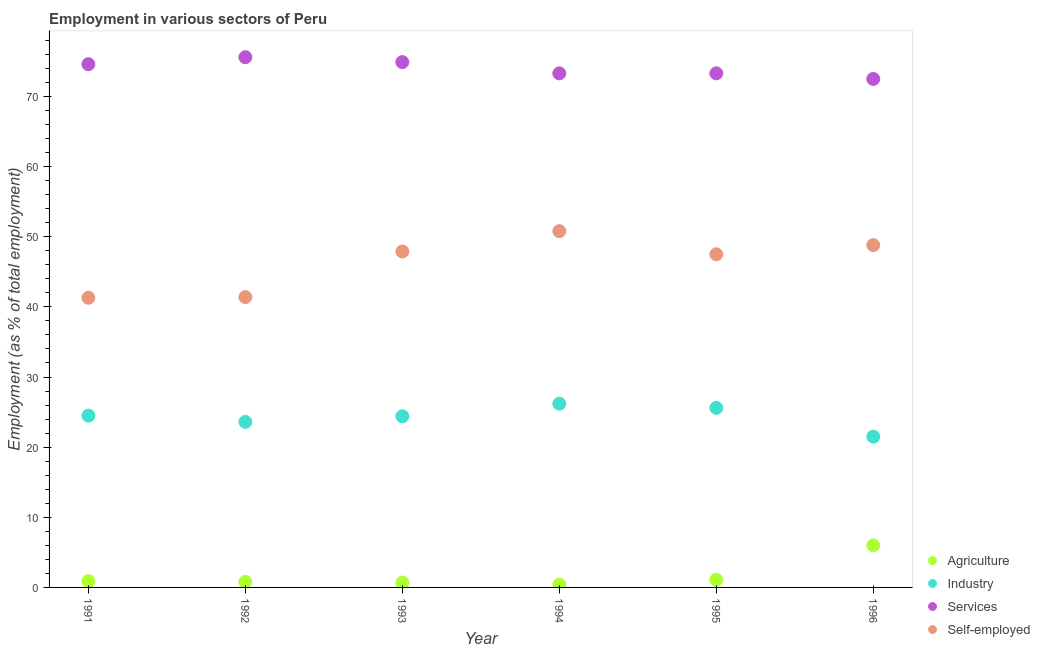How many different coloured dotlines are there?
Make the answer very short. 4. What is the percentage of workers in agriculture in 1992?
Keep it short and to the point. 0.8. Across all years, what is the maximum percentage of workers in agriculture?
Your answer should be very brief. 6. Across all years, what is the minimum percentage of workers in agriculture?
Keep it short and to the point. 0.4. In which year was the percentage of workers in agriculture maximum?
Offer a very short reply. 1996. In which year was the percentage of workers in services minimum?
Offer a terse response. 1996. What is the total percentage of self employed workers in the graph?
Your response must be concise. 277.7. What is the difference between the percentage of workers in agriculture in 1994 and that in 1995?
Provide a succinct answer. -0.7. What is the difference between the percentage of workers in agriculture in 1993 and the percentage of self employed workers in 1991?
Ensure brevity in your answer.  -40.6. What is the average percentage of workers in industry per year?
Keep it short and to the point. 24.3. In the year 1992, what is the difference between the percentage of self employed workers and percentage of workers in services?
Provide a succinct answer. -34.2. What is the ratio of the percentage of workers in services in 1992 to that in 1996?
Provide a short and direct response. 1.04. Is the difference between the percentage of workers in industry in 1991 and 1996 greater than the difference between the percentage of self employed workers in 1991 and 1996?
Provide a succinct answer. Yes. What is the difference between the highest and the second highest percentage of self employed workers?
Ensure brevity in your answer.  2. What is the difference between the highest and the lowest percentage of workers in industry?
Offer a terse response. 4.7. Is it the case that in every year, the sum of the percentage of workers in services and percentage of workers in agriculture is greater than the sum of percentage of workers in industry and percentage of self employed workers?
Keep it short and to the point. No. Is it the case that in every year, the sum of the percentage of workers in agriculture and percentage of workers in industry is greater than the percentage of workers in services?
Your answer should be compact. No. Is the percentage of workers in agriculture strictly less than the percentage of workers in industry over the years?
Your answer should be very brief. Yes. How many dotlines are there?
Offer a very short reply. 4. How many years are there in the graph?
Give a very brief answer. 6. What is the difference between two consecutive major ticks on the Y-axis?
Provide a succinct answer. 10. Are the values on the major ticks of Y-axis written in scientific E-notation?
Offer a very short reply. No. Does the graph contain any zero values?
Offer a very short reply. No. Does the graph contain grids?
Give a very brief answer. No. How many legend labels are there?
Offer a terse response. 4. How are the legend labels stacked?
Your answer should be very brief. Vertical. What is the title of the graph?
Your answer should be compact. Employment in various sectors of Peru. Does "UNHCR" appear as one of the legend labels in the graph?
Offer a terse response. No. What is the label or title of the X-axis?
Keep it short and to the point. Year. What is the label or title of the Y-axis?
Your response must be concise. Employment (as % of total employment). What is the Employment (as % of total employment) of Agriculture in 1991?
Your answer should be compact. 0.9. What is the Employment (as % of total employment) of Services in 1991?
Provide a succinct answer. 74.6. What is the Employment (as % of total employment) of Self-employed in 1991?
Offer a terse response. 41.3. What is the Employment (as % of total employment) in Agriculture in 1992?
Ensure brevity in your answer.  0.8. What is the Employment (as % of total employment) of Industry in 1992?
Offer a very short reply. 23.6. What is the Employment (as % of total employment) of Services in 1992?
Offer a very short reply. 75.6. What is the Employment (as % of total employment) in Self-employed in 1992?
Your answer should be very brief. 41.4. What is the Employment (as % of total employment) of Agriculture in 1993?
Give a very brief answer. 0.7. What is the Employment (as % of total employment) in Industry in 1993?
Provide a short and direct response. 24.4. What is the Employment (as % of total employment) of Services in 1993?
Ensure brevity in your answer.  74.9. What is the Employment (as % of total employment) in Self-employed in 1993?
Give a very brief answer. 47.9. What is the Employment (as % of total employment) of Agriculture in 1994?
Provide a succinct answer. 0.4. What is the Employment (as % of total employment) in Industry in 1994?
Ensure brevity in your answer.  26.2. What is the Employment (as % of total employment) in Services in 1994?
Provide a short and direct response. 73.3. What is the Employment (as % of total employment) in Self-employed in 1994?
Provide a short and direct response. 50.8. What is the Employment (as % of total employment) in Agriculture in 1995?
Provide a succinct answer. 1.1. What is the Employment (as % of total employment) in Industry in 1995?
Ensure brevity in your answer.  25.6. What is the Employment (as % of total employment) in Services in 1995?
Your response must be concise. 73.3. What is the Employment (as % of total employment) in Self-employed in 1995?
Give a very brief answer. 47.5. What is the Employment (as % of total employment) in Services in 1996?
Ensure brevity in your answer.  72.5. What is the Employment (as % of total employment) of Self-employed in 1996?
Give a very brief answer. 48.8. Across all years, what is the maximum Employment (as % of total employment) in Industry?
Ensure brevity in your answer.  26.2. Across all years, what is the maximum Employment (as % of total employment) of Services?
Keep it short and to the point. 75.6. Across all years, what is the maximum Employment (as % of total employment) of Self-employed?
Provide a succinct answer. 50.8. Across all years, what is the minimum Employment (as % of total employment) in Agriculture?
Offer a very short reply. 0.4. Across all years, what is the minimum Employment (as % of total employment) in Industry?
Provide a succinct answer. 21.5. Across all years, what is the minimum Employment (as % of total employment) of Services?
Provide a short and direct response. 72.5. Across all years, what is the minimum Employment (as % of total employment) in Self-employed?
Provide a succinct answer. 41.3. What is the total Employment (as % of total employment) in Industry in the graph?
Offer a terse response. 145.8. What is the total Employment (as % of total employment) in Services in the graph?
Give a very brief answer. 444.2. What is the total Employment (as % of total employment) in Self-employed in the graph?
Your response must be concise. 277.7. What is the difference between the Employment (as % of total employment) of Agriculture in 1991 and that in 1992?
Your answer should be compact. 0.1. What is the difference between the Employment (as % of total employment) in Industry in 1991 and that in 1992?
Your answer should be compact. 0.9. What is the difference between the Employment (as % of total employment) in Services in 1991 and that in 1992?
Your answer should be compact. -1. What is the difference between the Employment (as % of total employment) in Agriculture in 1991 and that in 1993?
Make the answer very short. 0.2. What is the difference between the Employment (as % of total employment) in Self-employed in 1991 and that in 1993?
Your response must be concise. -6.6. What is the difference between the Employment (as % of total employment) of Agriculture in 1991 and that in 1994?
Keep it short and to the point. 0.5. What is the difference between the Employment (as % of total employment) of Industry in 1991 and that in 1994?
Ensure brevity in your answer.  -1.7. What is the difference between the Employment (as % of total employment) in Services in 1991 and that in 1994?
Offer a terse response. 1.3. What is the difference between the Employment (as % of total employment) of Services in 1991 and that in 1995?
Provide a short and direct response. 1.3. What is the difference between the Employment (as % of total employment) of Self-employed in 1991 and that in 1995?
Give a very brief answer. -6.2. What is the difference between the Employment (as % of total employment) in Agriculture in 1991 and that in 1996?
Give a very brief answer. -5.1. What is the difference between the Employment (as % of total employment) in Industry in 1991 and that in 1996?
Provide a short and direct response. 3. What is the difference between the Employment (as % of total employment) in Industry in 1992 and that in 1993?
Make the answer very short. -0.8. What is the difference between the Employment (as % of total employment) of Services in 1992 and that in 1993?
Make the answer very short. 0.7. What is the difference between the Employment (as % of total employment) in Self-employed in 1992 and that in 1993?
Give a very brief answer. -6.5. What is the difference between the Employment (as % of total employment) of Agriculture in 1992 and that in 1994?
Make the answer very short. 0.4. What is the difference between the Employment (as % of total employment) in Industry in 1992 and that in 1994?
Offer a terse response. -2.6. What is the difference between the Employment (as % of total employment) of Self-employed in 1992 and that in 1994?
Your answer should be compact. -9.4. What is the difference between the Employment (as % of total employment) of Agriculture in 1992 and that in 1996?
Offer a terse response. -5.2. What is the difference between the Employment (as % of total employment) of Industry in 1992 and that in 1996?
Your answer should be very brief. 2.1. What is the difference between the Employment (as % of total employment) of Services in 1992 and that in 1996?
Your answer should be compact. 3.1. What is the difference between the Employment (as % of total employment) in Self-employed in 1992 and that in 1996?
Provide a short and direct response. -7.4. What is the difference between the Employment (as % of total employment) in Agriculture in 1993 and that in 1994?
Offer a terse response. 0.3. What is the difference between the Employment (as % of total employment) of Industry in 1993 and that in 1994?
Keep it short and to the point. -1.8. What is the difference between the Employment (as % of total employment) of Self-employed in 1993 and that in 1994?
Ensure brevity in your answer.  -2.9. What is the difference between the Employment (as % of total employment) in Agriculture in 1993 and that in 1995?
Keep it short and to the point. -0.4. What is the difference between the Employment (as % of total employment) in Services in 1993 and that in 1995?
Your response must be concise. 1.6. What is the difference between the Employment (as % of total employment) of Self-employed in 1993 and that in 1995?
Provide a succinct answer. 0.4. What is the difference between the Employment (as % of total employment) of Self-employed in 1993 and that in 1996?
Offer a terse response. -0.9. What is the difference between the Employment (as % of total employment) in Services in 1994 and that in 1995?
Keep it short and to the point. 0. What is the difference between the Employment (as % of total employment) of Agriculture in 1994 and that in 1996?
Keep it short and to the point. -5.6. What is the difference between the Employment (as % of total employment) of Services in 1994 and that in 1996?
Offer a very short reply. 0.8. What is the difference between the Employment (as % of total employment) in Industry in 1995 and that in 1996?
Provide a short and direct response. 4.1. What is the difference between the Employment (as % of total employment) in Agriculture in 1991 and the Employment (as % of total employment) in Industry in 1992?
Your answer should be very brief. -22.7. What is the difference between the Employment (as % of total employment) in Agriculture in 1991 and the Employment (as % of total employment) in Services in 1992?
Your answer should be very brief. -74.7. What is the difference between the Employment (as % of total employment) in Agriculture in 1991 and the Employment (as % of total employment) in Self-employed in 1992?
Your answer should be very brief. -40.5. What is the difference between the Employment (as % of total employment) in Industry in 1991 and the Employment (as % of total employment) in Services in 1992?
Your response must be concise. -51.1. What is the difference between the Employment (as % of total employment) in Industry in 1991 and the Employment (as % of total employment) in Self-employed in 1992?
Your response must be concise. -16.9. What is the difference between the Employment (as % of total employment) in Services in 1991 and the Employment (as % of total employment) in Self-employed in 1992?
Offer a very short reply. 33.2. What is the difference between the Employment (as % of total employment) of Agriculture in 1991 and the Employment (as % of total employment) of Industry in 1993?
Your answer should be very brief. -23.5. What is the difference between the Employment (as % of total employment) of Agriculture in 1991 and the Employment (as % of total employment) of Services in 1993?
Your answer should be very brief. -74. What is the difference between the Employment (as % of total employment) in Agriculture in 1991 and the Employment (as % of total employment) in Self-employed in 1993?
Ensure brevity in your answer.  -47. What is the difference between the Employment (as % of total employment) in Industry in 1991 and the Employment (as % of total employment) in Services in 1993?
Offer a very short reply. -50.4. What is the difference between the Employment (as % of total employment) of Industry in 1991 and the Employment (as % of total employment) of Self-employed in 1993?
Your answer should be very brief. -23.4. What is the difference between the Employment (as % of total employment) of Services in 1991 and the Employment (as % of total employment) of Self-employed in 1993?
Make the answer very short. 26.7. What is the difference between the Employment (as % of total employment) in Agriculture in 1991 and the Employment (as % of total employment) in Industry in 1994?
Offer a very short reply. -25.3. What is the difference between the Employment (as % of total employment) of Agriculture in 1991 and the Employment (as % of total employment) of Services in 1994?
Offer a very short reply. -72.4. What is the difference between the Employment (as % of total employment) of Agriculture in 1991 and the Employment (as % of total employment) of Self-employed in 1994?
Make the answer very short. -49.9. What is the difference between the Employment (as % of total employment) in Industry in 1991 and the Employment (as % of total employment) in Services in 1994?
Offer a very short reply. -48.8. What is the difference between the Employment (as % of total employment) of Industry in 1991 and the Employment (as % of total employment) of Self-employed in 1994?
Your answer should be very brief. -26.3. What is the difference between the Employment (as % of total employment) of Services in 1991 and the Employment (as % of total employment) of Self-employed in 1994?
Your response must be concise. 23.8. What is the difference between the Employment (as % of total employment) in Agriculture in 1991 and the Employment (as % of total employment) in Industry in 1995?
Keep it short and to the point. -24.7. What is the difference between the Employment (as % of total employment) of Agriculture in 1991 and the Employment (as % of total employment) of Services in 1995?
Make the answer very short. -72.4. What is the difference between the Employment (as % of total employment) of Agriculture in 1991 and the Employment (as % of total employment) of Self-employed in 1995?
Make the answer very short. -46.6. What is the difference between the Employment (as % of total employment) of Industry in 1991 and the Employment (as % of total employment) of Services in 1995?
Your response must be concise. -48.8. What is the difference between the Employment (as % of total employment) in Services in 1991 and the Employment (as % of total employment) in Self-employed in 1995?
Make the answer very short. 27.1. What is the difference between the Employment (as % of total employment) of Agriculture in 1991 and the Employment (as % of total employment) of Industry in 1996?
Give a very brief answer. -20.6. What is the difference between the Employment (as % of total employment) in Agriculture in 1991 and the Employment (as % of total employment) in Services in 1996?
Provide a short and direct response. -71.6. What is the difference between the Employment (as % of total employment) of Agriculture in 1991 and the Employment (as % of total employment) of Self-employed in 1996?
Provide a short and direct response. -47.9. What is the difference between the Employment (as % of total employment) in Industry in 1991 and the Employment (as % of total employment) in Services in 1996?
Make the answer very short. -48. What is the difference between the Employment (as % of total employment) of Industry in 1991 and the Employment (as % of total employment) of Self-employed in 1996?
Provide a short and direct response. -24.3. What is the difference between the Employment (as % of total employment) of Services in 1991 and the Employment (as % of total employment) of Self-employed in 1996?
Give a very brief answer. 25.8. What is the difference between the Employment (as % of total employment) of Agriculture in 1992 and the Employment (as % of total employment) of Industry in 1993?
Your answer should be compact. -23.6. What is the difference between the Employment (as % of total employment) of Agriculture in 1992 and the Employment (as % of total employment) of Services in 1993?
Ensure brevity in your answer.  -74.1. What is the difference between the Employment (as % of total employment) of Agriculture in 1992 and the Employment (as % of total employment) of Self-employed in 1993?
Provide a short and direct response. -47.1. What is the difference between the Employment (as % of total employment) in Industry in 1992 and the Employment (as % of total employment) in Services in 1993?
Your answer should be compact. -51.3. What is the difference between the Employment (as % of total employment) in Industry in 1992 and the Employment (as % of total employment) in Self-employed in 1993?
Provide a succinct answer. -24.3. What is the difference between the Employment (as % of total employment) of Services in 1992 and the Employment (as % of total employment) of Self-employed in 1993?
Provide a succinct answer. 27.7. What is the difference between the Employment (as % of total employment) in Agriculture in 1992 and the Employment (as % of total employment) in Industry in 1994?
Your answer should be very brief. -25.4. What is the difference between the Employment (as % of total employment) of Agriculture in 1992 and the Employment (as % of total employment) of Services in 1994?
Offer a very short reply. -72.5. What is the difference between the Employment (as % of total employment) of Agriculture in 1992 and the Employment (as % of total employment) of Self-employed in 1994?
Your answer should be very brief. -50. What is the difference between the Employment (as % of total employment) of Industry in 1992 and the Employment (as % of total employment) of Services in 1994?
Provide a succinct answer. -49.7. What is the difference between the Employment (as % of total employment) of Industry in 1992 and the Employment (as % of total employment) of Self-employed in 1994?
Keep it short and to the point. -27.2. What is the difference between the Employment (as % of total employment) of Services in 1992 and the Employment (as % of total employment) of Self-employed in 1994?
Provide a succinct answer. 24.8. What is the difference between the Employment (as % of total employment) of Agriculture in 1992 and the Employment (as % of total employment) of Industry in 1995?
Offer a very short reply. -24.8. What is the difference between the Employment (as % of total employment) of Agriculture in 1992 and the Employment (as % of total employment) of Services in 1995?
Make the answer very short. -72.5. What is the difference between the Employment (as % of total employment) in Agriculture in 1992 and the Employment (as % of total employment) in Self-employed in 1995?
Your answer should be very brief. -46.7. What is the difference between the Employment (as % of total employment) in Industry in 1992 and the Employment (as % of total employment) in Services in 1995?
Provide a succinct answer. -49.7. What is the difference between the Employment (as % of total employment) of Industry in 1992 and the Employment (as % of total employment) of Self-employed in 1995?
Your answer should be compact. -23.9. What is the difference between the Employment (as % of total employment) in Services in 1992 and the Employment (as % of total employment) in Self-employed in 1995?
Your answer should be very brief. 28.1. What is the difference between the Employment (as % of total employment) in Agriculture in 1992 and the Employment (as % of total employment) in Industry in 1996?
Your answer should be compact. -20.7. What is the difference between the Employment (as % of total employment) in Agriculture in 1992 and the Employment (as % of total employment) in Services in 1996?
Ensure brevity in your answer.  -71.7. What is the difference between the Employment (as % of total employment) in Agriculture in 1992 and the Employment (as % of total employment) in Self-employed in 1996?
Offer a very short reply. -48. What is the difference between the Employment (as % of total employment) in Industry in 1992 and the Employment (as % of total employment) in Services in 1996?
Ensure brevity in your answer.  -48.9. What is the difference between the Employment (as % of total employment) in Industry in 1992 and the Employment (as % of total employment) in Self-employed in 1996?
Provide a short and direct response. -25.2. What is the difference between the Employment (as % of total employment) in Services in 1992 and the Employment (as % of total employment) in Self-employed in 1996?
Provide a short and direct response. 26.8. What is the difference between the Employment (as % of total employment) of Agriculture in 1993 and the Employment (as % of total employment) of Industry in 1994?
Provide a short and direct response. -25.5. What is the difference between the Employment (as % of total employment) in Agriculture in 1993 and the Employment (as % of total employment) in Services in 1994?
Give a very brief answer. -72.6. What is the difference between the Employment (as % of total employment) of Agriculture in 1993 and the Employment (as % of total employment) of Self-employed in 1994?
Your answer should be very brief. -50.1. What is the difference between the Employment (as % of total employment) of Industry in 1993 and the Employment (as % of total employment) of Services in 1994?
Your answer should be compact. -48.9. What is the difference between the Employment (as % of total employment) of Industry in 1993 and the Employment (as % of total employment) of Self-employed in 1994?
Offer a terse response. -26.4. What is the difference between the Employment (as % of total employment) of Services in 1993 and the Employment (as % of total employment) of Self-employed in 1994?
Give a very brief answer. 24.1. What is the difference between the Employment (as % of total employment) in Agriculture in 1993 and the Employment (as % of total employment) in Industry in 1995?
Provide a short and direct response. -24.9. What is the difference between the Employment (as % of total employment) of Agriculture in 1993 and the Employment (as % of total employment) of Services in 1995?
Your answer should be compact. -72.6. What is the difference between the Employment (as % of total employment) of Agriculture in 1993 and the Employment (as % of total employment) of Self-employed in 1995?
Offer a terse response. -46.8. What is the difference between the Employment (as % of total employment) of Industry in 1993 and the Employment (as % of total employment) of Services in 1995?
Offer a very short reply. -48.9. What is the difference between the Employment (as % of total employment) in Industry in 1993 and the Employment (as % of total employment) in Self-employed in 1995?
Ensure brevity in your answer.  -23.1. What is the difference between the Employment (as % of total employment) in Services in 1993 and the Employment (as % of total employment) in Self-employed in 1995?
Offer a terse response. 27.4. What is the difference between the Employment (as % of total employment) in Agriculture in 1993 and the Employment (as % of total employment) in Industry in 1996?
Provide a short and direct response. -20.8. What is the difference between the Employment (as % of total employment) in Agriculture in 1993 and the Employment (as % of total employment) in Services in 1996?
Provide a short and direct response. -71.8. What is the difference between the Employment (as % of total employment) in Agriculture in 1993 and the Employment (as % of total employment) in Self-employed in 1996?
Your answer should be very brief. -48.1. What is the difference between the Employment (as % of total employment) of Industry in 1993 and the Employment (as % of total employment) of Services in 1996?
Give a very brief answer. -48.1. What is the difference between the Employment (as % of total employment) of Industry in 1993 and the Employment (as % of total employment) of Self-employed in 1996?
Provide a short and direct response. -24.4. What is the difference between the Employment (as % of total employment) of Services in 1993 and the Employment (as % of total employment) of Self-employed in 1996?
Your answer should be compact. 26.1. What is the difference between the Employment (as % of total employment) in Agriculture in 1994 and the Employment (as % of total employment) in Industry in 1995?
Provide a short and direct response. -25.2. What is the difference between the Employment (as % of total employment) of Agriculture in 1994 and the Employment (as % of total employment) of Services in 1995?
Your answer should be very brief. -72.9. What is the difference between the Employment (as % of total employment) in Agriculture in 1994 and the Employment (as % of total employment) in Self-employed in 1995?
Provide a short and direct response. -47.1. What is the difference between the Employment (as % of total employment) of Industry in 1994 and the Employment (as % of total employment) of Services in 1995?
Offer a terse response. -47.1. What is the difference between the Employment (as % of total employment) of Industry in 1994 and the Employment (as % of total employment) of Self-employed in 1995?
Ensure brevity in your answer.  -21.3. What is the difference between the Employment (as % of total employment) in Services in 1994 and the Employment (as % of total employment) in Self-employed in 1995?
Provide a succinct answer. 25.8. What is the difference between the Employment (as % of total employment) of Agriculture in 1994 and the Employment (as % of total employment) of Industry in 1996?
Offer a very short reply. -21.1. What is the difference between the Employment (as % of total employment) of Agriculture in 1994 and the Employment (as % of total employment) of Services in 1996?
Offer a terse response. -72.1. What is the difference between the Employment (as % of total employment) in Agriculture in 1994 and the Employment (as % of total employment) in Self-employed in 1996?
Offer a terse response. -48.4. What is the difference between the Employment (as % of total employment) of Industry in 1994 and the Employment (as % of total employment) of Services in 1996?
Provide a short and direct response. -46.3. What is the difference between the Employment (as % of total employment) in Industry in 1994 and the Employment (as % of total employment) in Self-employed in 1996?
Provide a succinct answer. -22.6. What is the difference between the Employment (as % of total employment) of Services in 1994 and the Employment (as % of total employment) of Self-employed in 1996?
Keep it short and to the point. 24.5. What is the difference between the Employment (as % of total employment) in Agriculture in 1995 and the Employment (as % of total employment) in Industry in 1996?
Keep it short and to the point. -20.4. What is the difference between the Employment (as % of total employment) in Agriculture in 1995 and the Employment (as % of total employment) in Services in 1996?
Offer a terse response. -71.4. What is the difference between the Employment (as % of total employment) in Agriculture in 1995 and the Employment (as % of total employment) in Self-employed in 1996?
Provide a short and direct response. -47.7. What is the difference between the Employment (as % of total employment) in Industry in 1995 and the Employment (as % of total employment) in Services in 1996?
Provide a succinct answer. -46.9. What is the difference between the Employment (as % of total employment) in Industry in 1995 and the Employment (as % of total employment) in Self-employed in 1996?
Give a very brief answer. -23.2. What is the difference between the Employment (as % of total employment) of Services in 1995 and the Employment (as % of total employment) of Self-employed in 1996?
Offer a very short reply. 24.5. What is the average Employment (as % of total employment) in Agriculture per year?
Provide a succinct answer. 1.65. What is the average Employment (as % of total employment) in Industry per year?
Give a very brief answer. 24.3. What is the average Employment (as % of total employment) in Services per year?
Make the answer very short. 74.03. What is the average Employment (as % of total employment) in Self-employed per year?
Provide a succinct answer. 46.28. In the year 1991, what is the difference between the Employment (as % of total employment) of Agriculture and Employment (as % of total employment) of Industry?
Give a very brief answer. -23.6. In the year 1991, what is the difference between the Employment (as % of total employment) of Agriculture and Employment (as % of total employment) of Services?
Offer a terse response. -73.7. In the year 1991, what is the difference between the Employment (as % of total employment) in Agriculture and Employment (as % of total employment) in Self-employed?
Your response must be concise. -40.4. In the year 1991, what is the difference between the Employment (as % of total employment) of Industry and Employment (as % of total employment) of Services?
Keep it short and to the point. -50.1. In the year 1991, what is the difference between the Employment (as % of total employment) of Industry and Employment (as % of total employment) of Self-employed?
Provide a short and direct response. -16.8. In the year 1991, what is the difference between the Employment (as % of total employment) of Services and Employment (as % of total employment) of Self-employed?
Provide a succinct answer. 33.3. In the year 1992, what is the difference between the Employment (as % of total employment) in Agriculture and Employment (as % of total employment) in Industry?
Provide a succinct answer. -22.8. In the year 1992, what is the difference between the Employment (as % of total employment) of Agriculture and Employment (as % of total employment) of Services?
Your answer should be compact. -74.8. In the year 1992, what is the difference between the Employment (as % of total employment) in Agriculture and Employment (as % of total employment) in Self-employed?
Your answer should be very brief. -40.6. In the year 1992, what is the difference between the Employment (as % of total employment) in Industry and Employment (as % of total employment) in Services?
Offer a very short reply. -52. In the year 1992, what is the difference between the Employment (as % of total employment) in Industry and Employment (as % of total employment) in Self-employed?
Keep it short and to the point. -17.8. In the year 1992, what is the difference between the Employment (as % of total employment) of Services and Employment (as % of total employment) of Self-employed?
Offer a very short reply. 34.2. In the year 1993, what is the difference between the Employment (as % of total employment) of Agriculture and Employment (as % of total employment) of Industry?
Make the answer very short. -23.7. In the year 1993, what is the difference between the Employment (as % of total employment) of Agriculture and Employment (as % of total employment) of Services?
Keep it short and to the point. -74.2. In the year 1993, what is the difference between the Employment (as % of total employment) in Agriculture and Employment (as % of total employment) in Self-employed?
Offer a very short reply. -47.2. In the year 1993, what is the difference between the Employment (as % of total employment) in Industry and Employment (as % of total employment) in Services?
Ensure brevity in your answer.  -50.5. In the year 1993, what is the difference between the Employment (as % of total employment) in Industry and Employment (as % of total employment) in Self-employed?
Your answer should be compact. -23.5. In the year 1994, what is the difference between the Employment (as % of total employment) of Agriculture and Employment (as % of total employment) of Industry?
Keep it short and to the point. -25.8. In the year 1994, what is the difference between the Employment (as % of total employment) in Agriculture and Employment (as % of total employment) in Services?
Ensure brevity in your answer.  -72.9. In the year 1994, what is the difference between the Employment (as % of total employment) in Agriculture and Employment (as % of total employment) in Self-employed?
Provide a succinct answer. -50.4. In the year 1994, what is the difference between the Employment (as % of total employment) of Industry and Employment (as % of total employment) of Services?
Provide a short and direct response. -47.1. In the year 1994, what is the difference between the Employment (as % of total employment) of Industry and Employment (as % of total employment) of Self-employed?
Give a very brief answer. -24.6. In the year 1995, what is the difference between the Employment (as % of total employment) in Agriculture and Employment (as % of total employment) in Industry?
Your response must be concise. -24.5. In the year 1995, what is the difference between the Employment (as % of total employment) of Agriculture and Employment (as % of total employment) of Services?
Give a very brief answer. -72.2. In the year 1995, what is the difference between the Employment (as % of total employment) in Agriculture and Employment (as % of total employment) in Self-employed?
Your answer should be very brief. -46.4. In the year 1995, what is the difference between the Employment (as % of total employment) of Industry and Employment (as % of total employment) of Services?
Your response must be concise. -47.7. In the year 1995, what is the difference between the Employment (as % of total employment) in Industry and Employment (as % of total employment) in Self-employed?
Your answer should be compact. -21.9. In the year 1995, what is the difference between the Employment (as % of total employment) of Services and Employment (as % of total employment) of Self-employed?
Make the answer very short. 25.8. In the year 1996, what is the difference between the Employment (as % of total employment) of Agriculture and Employment (as % of total employment) of Industry?
Keep it short and to the point. -15.5. In the year 1996, what is the difference between the Employment (as % of total employment) in Agriculture and Employment (as % of total employment) in Services?
Offer a terse response. -66.5. In the year 1996, what is the difference between the Employment (as % of total employment) in Agriculture and Employment (as % of total employment) in Self-employed?
Give a very brief answer. -42.8. In the year 1996, what is the difference between the Employment (as % of total employment) of Industry and Employment (as % of total employment) of Services?
Your answer should be compact. -51. In the year 1996, what is the difference between the Employment (as % of total employment) of Industry and Employment (as % of total employment) of Self-employed?
Your response must be concise. -27.3. In the year 1996, what is the difference between the Employment (as % of total employment) in Services and Employment (as % of total employment) in Self-employed?
Provide a succinct answer. 23.7. What is the ratio of the Employment (as % of total employment) of Agriculture in 1991 to that in 1992?
Ensure brevity in your answer.  1.12. What is the ratio of the Employment (as % of total employment) of Industry in 1991 to that in 1992?
Ensure brevity in your answer.  1.04. What is the ratio of the Employment (as % of total employment) of Services in 1991 to that in 1992?
Offer a terse response. 0.99. What is the ratio of the Employment (as % of total employment) of Self-employed in 1991 to that in 1992?
Provide a succinct answer. 1. What is the ratio of the Employment (as % of total employment) in Agriculture in 1991 to that in 1993?
Make the answer very short. 1.29. What is the ratio of the Employment (as % of total employment) in Industry in 1991 to that in 1993?
Your answer should be very brief. 1. What is the ratio of the Employment (as % of total employment) in Self-employed in 1991 to that in 1993?
Provide a succinct answer. 0.86. What is the ratio of the Employment (as % of total employment) in Agriculture in 1991 to that in 1994?
Give a very brief answer. 2.25. What is the ratio of the Employment (as % of total employment) in Industry in 1991 to that in 1994?
Your response must be concise. 0.94. What is the ratio of the Employment (as % of total employment) in Services in 1991 to that in 1994?
Your answer should be compact. 1.02. What is the ratio of the Employment (as % of total employment) in Self-employed in 1991 to that in 1994?
Offer a very short reply. 0.81. What is the ratio of the Employment (as % of total employment) in Agriculture in 1991 to that in 1995?
Your answer should be compact. 0.82. What is the ratio of the Employment (as % of total employment) in Services in 1991 to that in 1995?
Ensure brevity in your answer.  1.02. What is the ratio of the Employment (as % of total employment) in Self-employed in 1991 to that in 1995?
Give a very brief answer. 0.87. What is the ratio of the Employment (as % of total employment) of Industry in 1991 to that in 1996?
Your answer should be compact. 1.14. What is the ratio of the Employment (as % of total employment) of Services in 1991 to that in 1996?
Make the answer very short. 1.03. What is the ratio of the Employment (as % of total employment) in Self-employed in 1991 to that in 1996?
Your answer should be compact. 0.85. What is the ratio of the Employment (as % of total employment) of Agriculture in 1992 to that in 1993?
Make the answer very short. 1.14. What is the ratio of the Employment (as % of total employment) of Industry in 1992 to that in 1993?
Provide a succinct answer. 0.97. What is the ratio of the Employment (as % of total employment) in Services in 1992 to that in 1993?
Your answer should be compact. 1.01. What is the ratio of the Employment (as % of total employment) in Self-employed in 1992 to that in 1993?
Ensure brevity in your answer.  0.86. What is the ratio of the Employment (as % of total employment) in Agriculture in 1992 to that in 1994?
Offer a very short reply. 2. What is the ratio of the Employment (as % of total employment) of Industry in 1992 to that in 1994?
Your answer should be very brief. 0.9. What is the ratio of the Employment (as % of total employment) of Services in 1992 to that in 1994?
Give a very brief answer. 1.03. What is the ratio of the Employment (as % of total employment) in Self-employed in 1992 to that in 1994?
Your answer should be very brief. 0.81. What is the ratio of the Employment (as % of total employment) of Agriculture in 1992 to that in 1995?
Ensure brevity in your answer.  0.73. What is the ratio of the Employment (as % of total employment) in Industry in 1992 to that in 1995?
Give a very brief answer. 0.92. What is the ratio of the Employment (as % of total employment) of Services in 1992 to that in 1995?
Give a very brief answer. 1.03. What is the ratio of the Employment (as % of total employment) in Self-employed in 1992 to that in 1995?
Keep it short and to the point. 0.87. What is the ratio of the Employment (as % of total employment) in Agriculture in 1992 to that in 1996?
Keep it short and to the point. 0.13. What is the ratio of the Employment (as % of total employment) in Industry in 1992 to that in 1996?
Offer a very short reply. 1.1. What is the ratio of the Employment (as % of total employment) of Services in 1992 to that in 1996?
Your answer should be compact. 1.04. What is the ratio of the Employment (as % of total employment) in Self-employed in 1992 to that in 1996?
Give a very brief answer. 0.85. What is the ratio of the Employment (as % of total employment) in Industry in 1993 to that in 1994?
Offer a very short reply. 0.93. What is the ratio of the Employment (as % of total employment) in Services in 1993 to that in 1994?
Your answer should be compact. 1.02. What is the ratio of the Employment (as % of total employment) in Self-employed in 1993 to that in 1994?
Provide a succinct answer. 0.94. What is the ratio of the Employment (as % of total employment) of Agriculture in 1993 to that in 1995?
Provide a short and direct response. 0.64. What is the ratio of the Employment (as % of total employment) in Industry in 1993 to that in 1995?
Keep it short and to the point. 0.95. What is the ratio of the Employment (as % of total employment) in Services in 1993 to that in 1995?
Offer a very short reply. 1.02. What is the ratio of the Employment (as % of total employment) in Self-employed in 1993 to that in 1995?
Keep it short and to the point. 1.01. What is the ratio of the Employment (as % of total employment) in Agriculture in 1993 to that in 1996?
Your answer should be compact. 0.12. What is the ratio of the Employment (as % of total employment) in Industry in 1993 to that in 1996?
Offer a very short reply. 1.13. What is the ratio of the Employment (as % of total employment) in Services in 1993 to that in 1996?
Provide a short and direct response. 1.03. What is the ratio of the Employment (as % of total employment) of Self-employed in 1993 to that in 1996?
Provide a short and direct response. 0.98. What is the ratio of the Employment (as % of total employment) of Agriculture in 1994 to that in 1995?
Ensure brevity in your answer.  0.36. What is the ratio of the Employment (as % of total employment) of Industry in 1994 to that in 1995?
Give a very brief answer. 1.02. What is the ratio of the Employment (as % of total employment) of Services in 1994 to that in 1995?
Provide a short and direct response. 1. What is the ratio of the Employment (as % of total employment) of Self-employed in 1994 to that in 1995?
Your response must be concise. 1.07. What is the ratio of the Employment (as % of total employment) of Agriculture in 1994 to that in 1996?
Make the answer very short. 0.07. What is the ratio of the Employment (as % of total employment) of Industry in 1994 to that in 1996?
Provide a succinct answer. 1.22. What is the ratio of the Employment (as % of total employment) of Services in 1994 to that in 1996?
Offer a terse response. 1.01. What is the ratio of the Employment (as % of total employment) in Self-employed in 1994 to that in 1996?
Offer a terse response. 1.04. What is the ratio of the Employment (as % of total employment) in Agriculture in 1995 to that in 1996?
Your response must be concise. 0.18. What is the ratio of the Employment (as % of total employment) in Industry in 1995 to that in 1996?
Offer a very short reply. 1.19. What is the ratio of the Employment (as % of total employment) of Self-employed in 1995 to that in 1996?
Ensure brevity in your answer.  0.97. What is the difference between the highest and the second highest Employment (as % of total employment) in Industry?
Offer a very short reply. 0.6. What is the difference between the highest and the second highest Employment (as % of total employment) in Services?
Keep it short and to the point. 0.7. What is the difference between the highest and the second highest Employment (as % of total employment) of Self-employed?
Your answer should be very brief. 2. What is the difference between the highest and the lowest Employment (as % of total employment) in Industry?
Keep it short and to the point. 4.7. What is the difference between the highest and the lowest Employment (as % of total employment) of Services?
Your response must be concise. 3.1. What is the difference between the highest and the lowest Employment (as % of total employment) of Self-employed?
Provide a short and direct response. 9.5. 